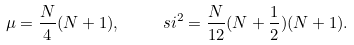<formula> <loc_0><loc_0><loc_500><loc_500>\mu = \frac { N } { 4 } ( N + 1 ) , \quad \ s i ^ { 2 } = \frac { N } { 1 2 } ( N + \frac { 1 } { 2 } ) ( N + 1 ) .</formula> 